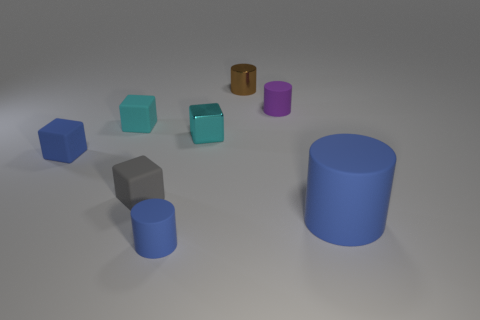Are there any other things that are the same color as the small metallic cube?
Keep it short and to the point. Yes. Is there another tiny brown object of the same shape as the brown shiny object?
Provide a succinct answer. No. There is a brown metal object that is the same size as the gray cube; what is its shape?
Provide a succinct answer. Cylinder. Are there any small objects that are in front of the tiny blue matte object left of the tiny blue matte thing that is in front of the tiny blue rubber block?
Give a very brief answer. Yes. Is there a green rubber cube that has the same size as the blue rubber cube?
Make the answer very short. No. What is the size of the matte cylinder behind the gray block?
Provide a short and direct response. Small. There is a tiny block that is right of the matte cylinder on the left side of the matte cylinder that is behind the small cyan matte object; what is its color?
Your answer should be compact. Cyan. There is a metallic thing behind the small shiny object on the left side of the small brown metal thing; what color is it?
Give a very brief answer. Brown. Are there more small cyan shiny blocks that are in front of the gray cube than metal cylinders that are on the right side of the big blue matte object?
Offer a terse response. No. Is the cyan block that is on the right side of the small cyan rubber block made of the same material as the tiny object on the right side of the metal cylinder?
Offer a very short reply. No. 